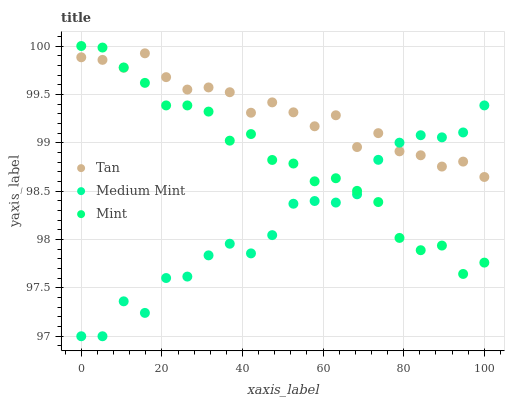Does Medium Mint have the minimum area under the curve?
Answer yes or no. Yes. Does Tan have the maximum area under the curve?
Answer yes or no. Yes. Does Mint have the minimum area under the curve?
Answer yes or no. No. Does Mint have the maximum area under the curve?
Answer yes or no. No. Is Mint the smoothest?
Answer yes or no. Yes. Is Medium Mint the roughest?
Answer yes or no. Yes. Is Tan the smoothest?
Answer yes or no. No. Is Tan the roughest?
Answer yes or no. No. Does Medium Mint have the lowest value?
Answer yes or no. Yes. Does Mint have the lowest value?
Answer yes or no. No. Does Mint have the highest value?
Answer yes or no. Yes. Does Tan have the highest value?
Answer yes or no. No. Does Tan intersect Mint?
Answer yes or no. Yes. Is Tan less than Mint?
Answer yes or no. No. Is Tan greater than Mint?
Answer yes or no. No. 